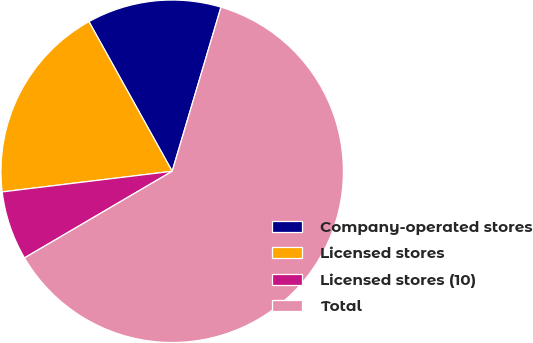Convert chart. <chart><loc_0><loc_0><loc_500><loc_500><pie_chart><fcel>Company-operated stores<fcel>Licensed stores<fcel>Licensed stores (10)<fcel>Total<nl><fcel>12.68%<fcel>18.84%<fcel>6.52%<fcel>61.95%<nl></chart> 